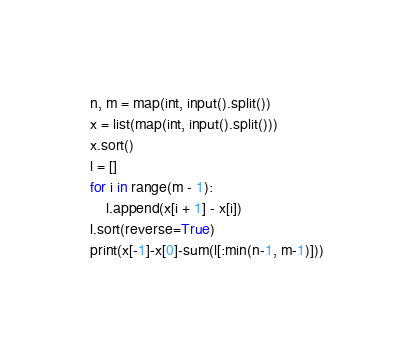Convert code to text. <code><loc_0><loc_0><loc_500><loc_500><_Python_>n, m = map(int, input().split())
x = list(map(int, input().split()))
x.sort()
l = []
for i in range(m - 1):
    l.append(x[i + 1] - x[i])
l.sort(reverse=True)
print(x[-1]-x[0]-sum(l[:min(n-1, m-1)]))
</code> 